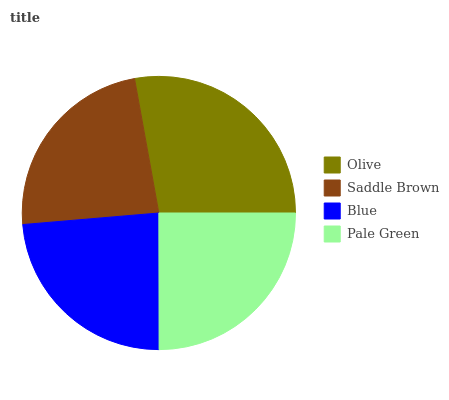Is Saddle Brown the minimum?
Answer yes or no. Yes. Is Olive the maximum?
Answer yes or no. Yes. Is Blue the minimum?
Answer yes or no. No. Is Blue the maximum?
Answer yes or no. No. Is Blue greater than Saddle Brown?
Answer yes or no. Yes. Is Saddle Brown less than Blue?
Answer yes or no. Yes. Is Saddle Brown greater than Blue?
Answer yes or no. No. Is Blue less than Saddle Brown?
Answer yes or no. No. Is Pale Green the high median?
Answer yes or no. Yes. Is Blue the low median?
Answer yes or no. Yes. Is Olive the high median?
Answer yes or no. No. Is Pale Green the low median?
Answer yes or no. No. 